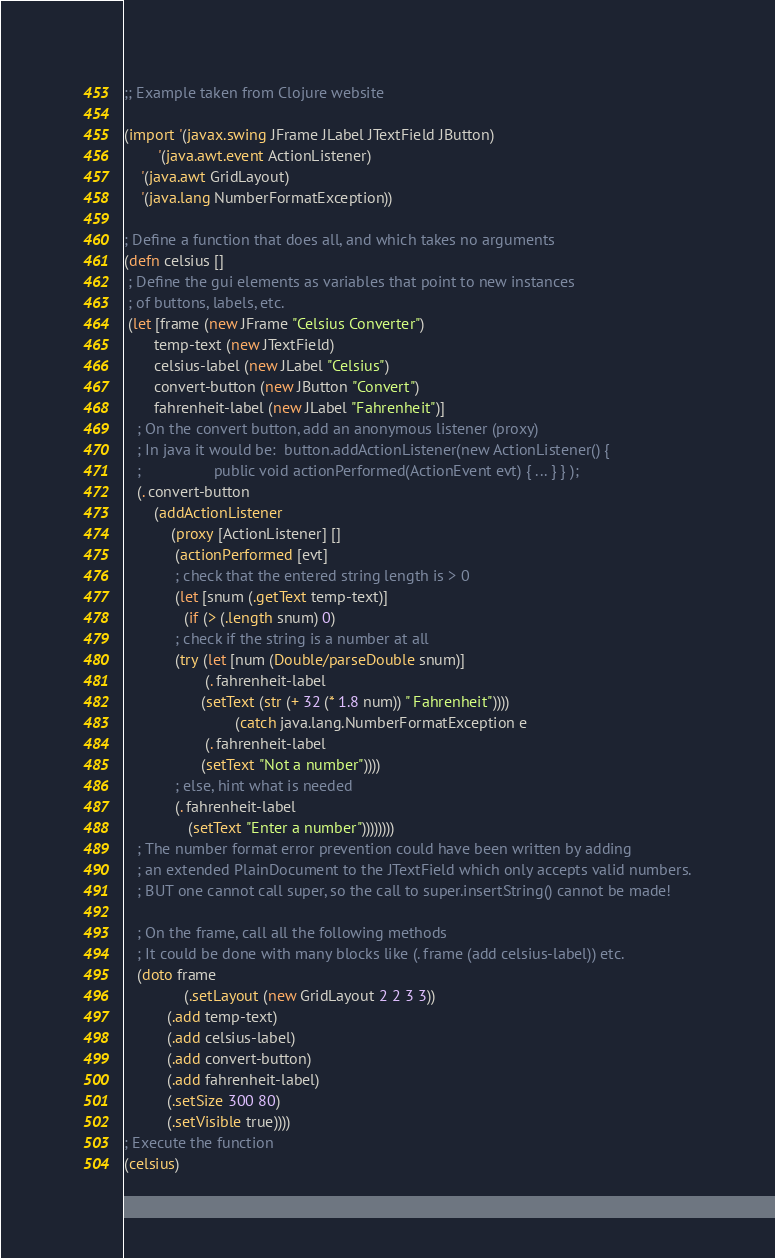Convert code to text. <code><loc_0><loc_0><loc_500><loc_500><_Clojure_>;; Example taken from Clojure website

(import '(javax.swing JFrame JLabel JTextField JButton)
        '(java.awt.event ActionListener)
	'(java.awt GridLayout)
	'(java.lang NumberFormatException))

; Define a function that does all, and which takes no arguments
(defn celsius []
 ; Define the gui elements as variables that point to new instances
 ; of buttons, labels, etc.
 (let [frame (new JFrame "Celsius Converter")
       temp-text (new JTextField)
       celsius-label (new JLabel "Celsius")
       convert-button (new JButton "Convert")
       fahrenheit-label (new JLabel "Fahrenheit")]
   ; On the convert button, add an anonymous listener (proxy)
   ; In java it would be:  button.addActionListener(new ActionListener() {
   ;                 public void actionPerformed(ActionEvent evt) { ... } } );
   (. convert-button
       (addActionListener
           (proxy [ActionListener] []
	        (actionPerformed [evt]
		    ; check that the entered string length is > 0
		    (let [snum (.getText temp-text)]
		      (if (> (.length snum) 0)
			; check if the string is a number at all
			(try (let [num (Double/parseDouble snum)]
			       (. fahrenheit-label
				  (setText (str (+ 32 (* 1.8 num)) " Fahrenheit"))))
                          (catch java.lang.NumberFormatException e
			       (. fahrenheit-label
				  (setText "Not a number"))))
			; else, hint what is needed
			(. fahrenheit-label
			   (setText "Enter a number"))))))))
   ; The number format error prevention could have been written by adding
   ; an extended PlainDocument to the JTextField which only accepts valid numbers.
   ; BUT one cannot call super, so the call to super.insertString() cannot be made!

   ; On the frame, call all the following methods
   ; It could be done with many blocks like (. frame (add celsius-label)) etc.
   (doto frame
              (.setLayout (new GridLayout 2 2 3 3))
	      (.add temp-text)
	      (.add celsius-label)
	      (.add convert-button)
	      (.add fahrenheit-label)
	      (.setSize 300 80)
	      (.setVisible true))))
; Execute the function
(celsius)
</code> 